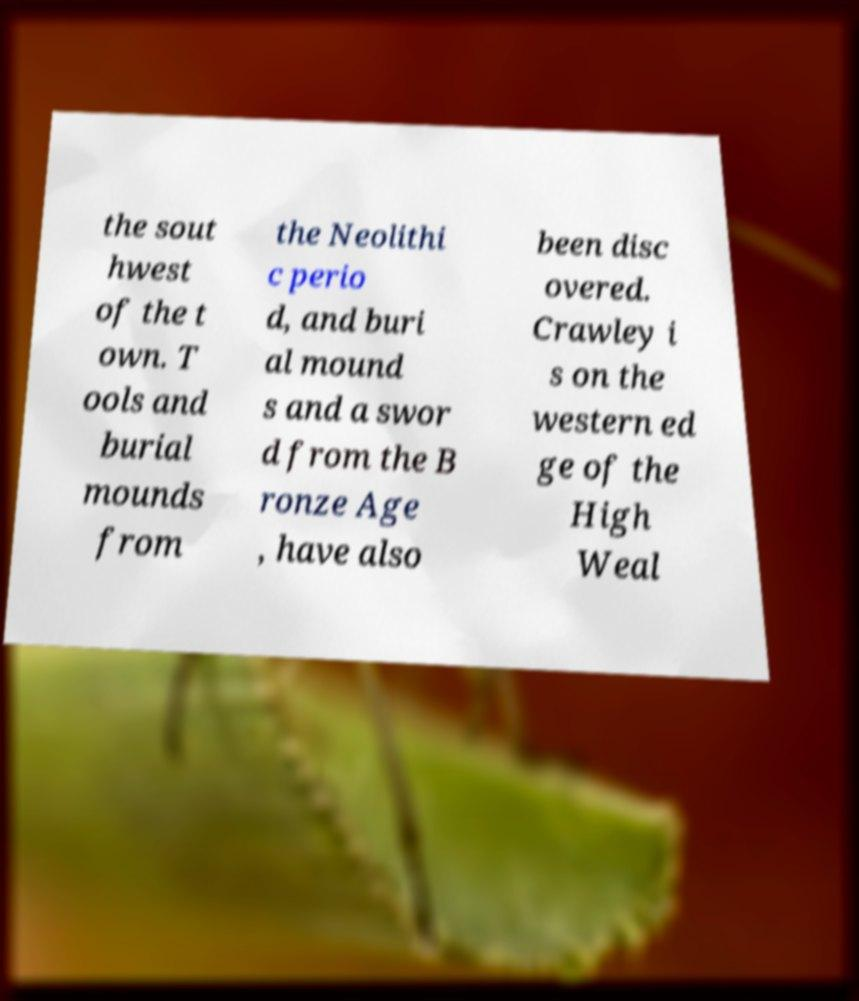Could you assist in decoding the text presented in this image and type it out clearly? the sout hwest of the t own. T ools and burial mounds from the Neolithi c perio d, and buri al mound s and a swor d from the B ronze Age , have also been disc overed. Crawley i s on the western ed ge of the High Weal 